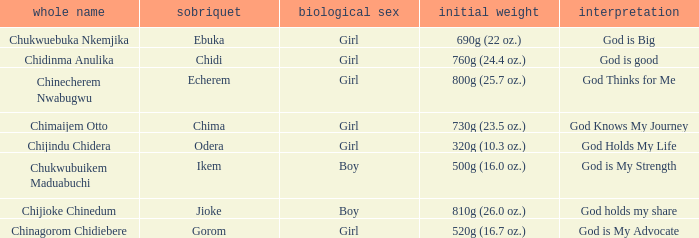How much did the girl, nicknamed Chidi, weigh at birth? 760g (24.4 oz.). 